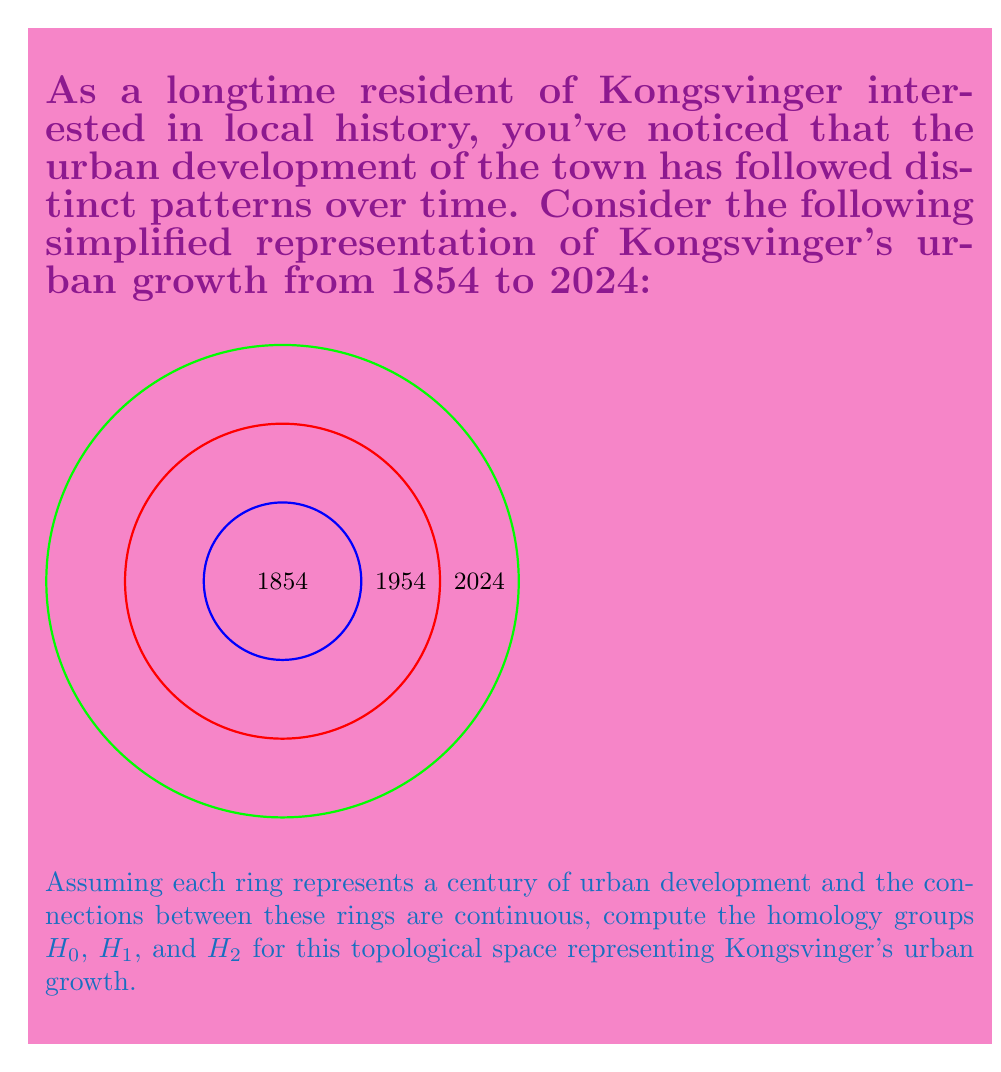Help me with this question. To compute the homology groups of Kongsvinger's urban development pattern, we'll follow these steps:

1) First, let's identify the topological space:
   The space is essentially three concentric circles, which topologically is equivalent to an annulus (a ring-shaped region).

2) For $H_0$ (0-dimensional homology):
   $H_0$ counts the number of connected components. In this case, we have one connected component (the entire annulus).
   Therefore, $H_0 \cong \mathbb{Z}$

3) For $H_1$ (1-dimensional homology):
   $H_1$ counts the number of 1-dimensional holes. In an annulus, there is one hole (the central area).
   Therefore, $H_1 \cong \mathbb{Z}$

4) For $H_2$ (2-dimensional homology):
   $H_2$ counts the number of 2-dimensional voids. The annulus is a 2-dimensional object without any 3-dimensional voids.
   Therefore, $H_2 \cong 0$

5) Higher dimensional homology groups ($H_n$ for $n \geq 3$) are all trivial (0) as the space is 2-dimensional.

In summary, the homology groups for Kongsvinger's urban development pattern are:

$$H_0 \cong \mathbb{Z}$$
$$H_1 \cong \mathbb{Z}$$
$$H_2 \cong 0$$
$$H_n \cong 0 \text{ for } n \geq 3$$
Answer: $H_0 \cong \mathbb{Z}, H_1 \cong \mathbb{Z}, H_2 \cong 0, H_n \cong 0 \text{ for } n \geq 3$ 